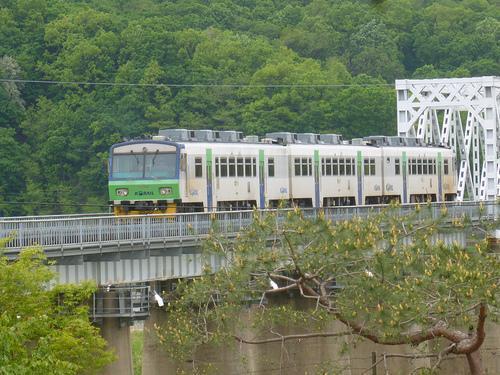How many trains are there?
Give a very brief answer. 1. 